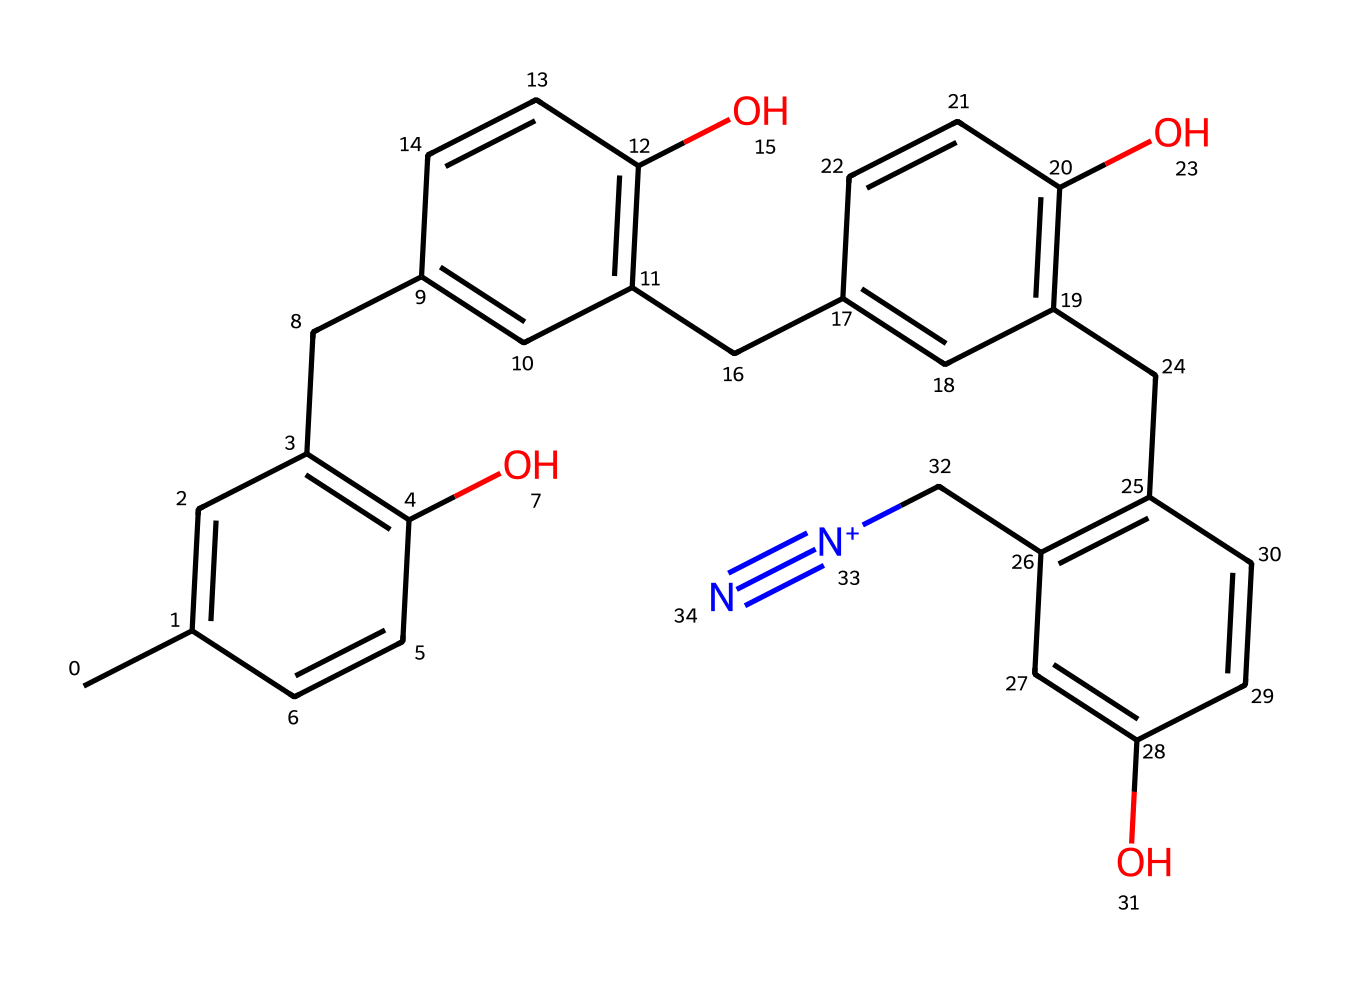What is the molecular formula of DNQ-Novolac based on its structure? To derive the molecular formula, I will count the number of carbon (C), hydrogen (H), oxygen (O), and nitrogen (N) atoms from the SMILES representation. The structure indicates there are 20 carbon atoms, 20 hydrogen atoms, 4 oxygen atoms, and 1 nitrogen atom. Therefore, the molecular formula is C20H20N1O4.
Answer: C20H20N1O4 How many hydroxyl (-OH) groups are present in DNQ-Novolac? By examining the structure, I can identify hydroxyl groups, which are indicated by the presence of oxygen atoms bonded to hydrogen atoms. In the SMILES representation, there are four -OH groups visible in the structure.
Answer: 4 What type of functional groups can be identified in DNQ-Novolac? Looking at the structure, I can identify phenolic hydroxyl groups and a nitro group (since there is a [N+] and a cyano group, indicated by #N). The presence of -OH groups confirms the phenolic nature, and the presence of nitrogen indicates nitro functionality.
Answer: phenolic hydroxyl, nitro group What is the significance of the azole ring in this photoresist? The azole ring, indicated by the presence of nitrogen in a carbon ring, plays a crucial role in the photoresist's properties, as it can significantly affect light absorption and chemical reactivity during the exposure process in semiconductor manufacturing.
Answer: light absorption How many double bonds are present in the chemical structure of DNQ-Novolac? By systematically analyzing the structure, I can count the double bonds represented in the rings and connections between carbon atoms. I find a total of six double bonds throughout the molecule.
Answer: 6 What is the role of phenolic groups in DNQ-Novolac? The phenolic groups provide photosensitivity to the photoresist, as they undergo chemical changes upon exposure to light, aiding in the process of pattern formation during semiconductor manufacturing.
Answer: photosensitivity 